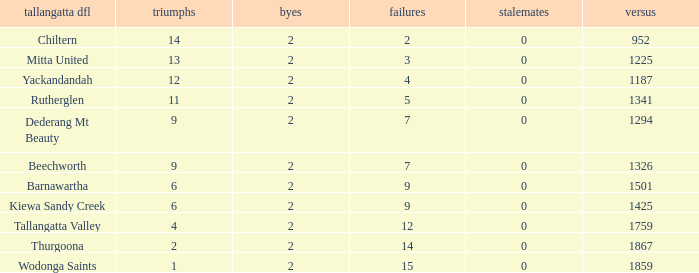What are the fewest draws with less than 7 losses and Mitta United is the Tallagatta DFL? 0.0. 